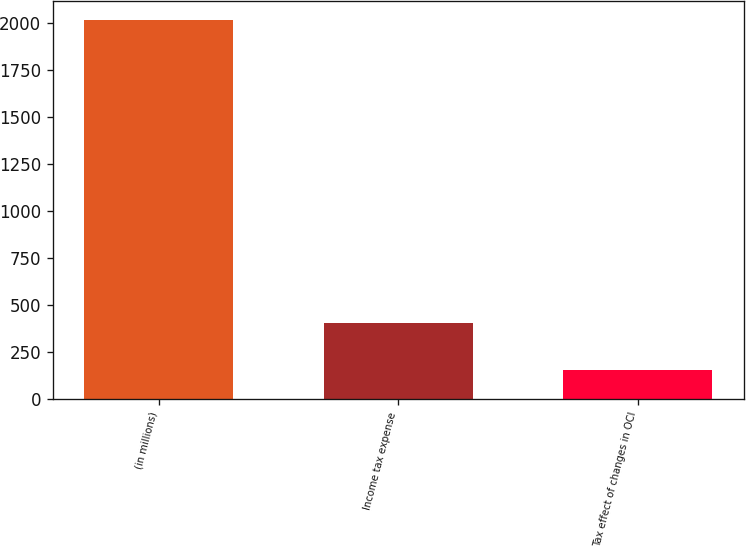<chart> <loc_0><loc_0><loc_500><loc_500><bar_chart><fcel>(in millions)<fcel>Income tax expense<fcel>Tax effect of changes in OCI<nl><fcel>2014<fcel>403<fcel>154<nl></chart> 